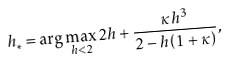Convert formula to latex. <formula><loc_0><loc_0><loc_500><loc_500>h _ { * } = \arg \max _ { h < 2 } 2 h + \frac { \kappa h ^ { 3 } } { 2 - h \left ( 1 + \kappa \right ) } ,</formula> 